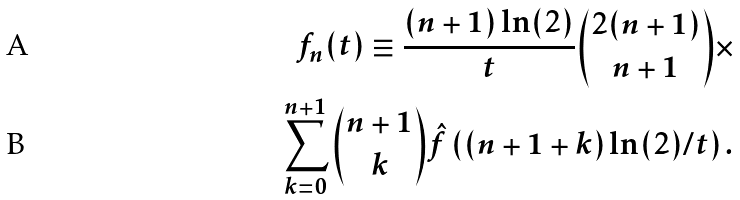Convert formula to latex. <formula><loc_0><loc_0><loc_500><loc_500>f _ { n } ( t ) \equiv \frac { ( n + 1 ) \ln ( 2 ) } { t } \binom { 2 ( n + 1 ) } { n + 1 } \times \\ \sum _ { k = 0 } ^ { n + 1 } \binom { n + 1 } { k } \hat { f } \left ( ( n + 1 + k ) \ln ( 2 ) / t \right ) .</formula> 